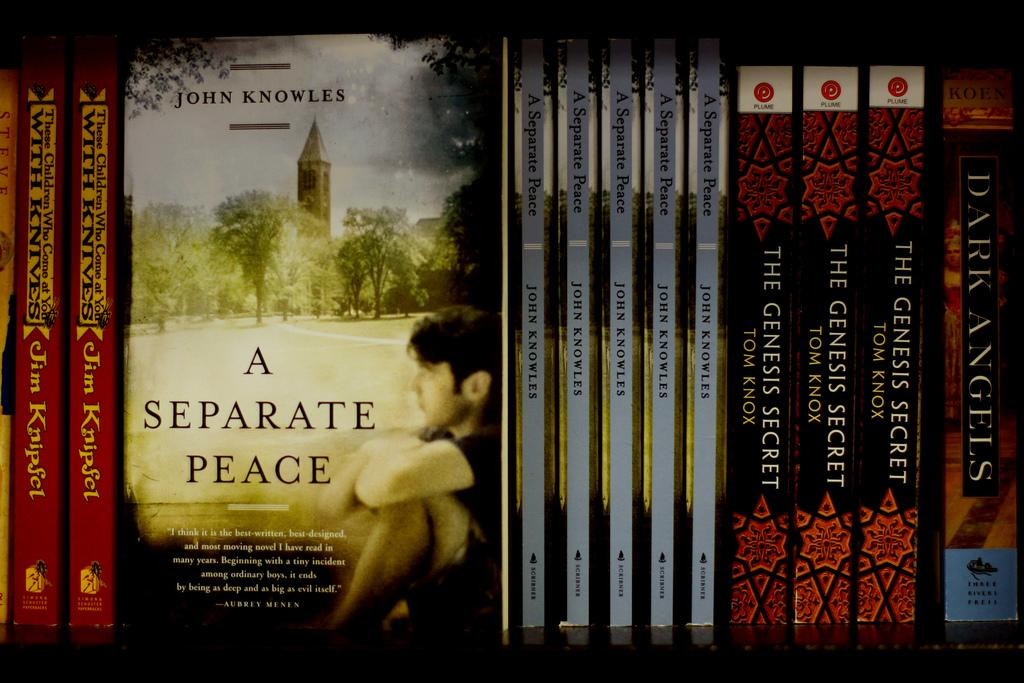Provide a one-sentence caption for the provided image. books like A separate Peace and The Genesis Secret lined up on a shelf. 